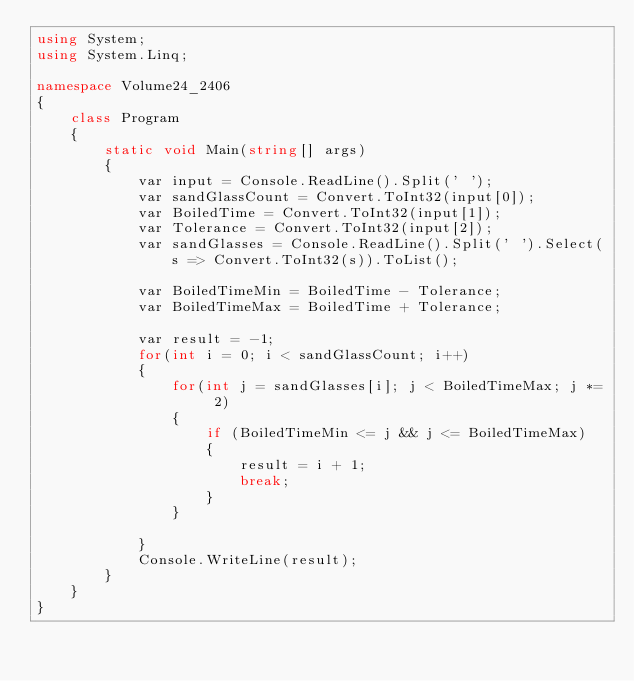Convert code to text. <code><loc_0><loc_0><loc_500><loc_500><_C#_>using System;
using System.Linq;

namespace Volume24_2406
{
    class Program
    {
        static void Main(string[] args)
        {
            var input = Console.ReadLine().Split(' ');
            var sandGlassCount = Convert.ToInt32(input[0]);
            var BoiledTime = Convert.ToInt32(input[1]);
            var Tolerance = Convert.ToInt32(input[2]);
            var sandGlasses = Console.ReadLine().Split(' ').Select(s => Convert.ToInt32(s)).ToList();

            var BoiledTimeMin = BoiledTime - Tolerance;
            var BoiledTimeMax = BoiledTime + Tolerance;

            var result = -1;
            for(int i = 0; i < sandGlassCount; i++)
            {
                for(int j = sandGlasses[i]; j < BoiledTimeMax; j *= 2)
                {
                    if (BoiledTimeMin <= j && j <= BoiledTimeMax)
                    {
                        result = i + 1;
                        break;
                    }
                }

            }
            Console.WriteLine(result);
        }
    }
}</code> 